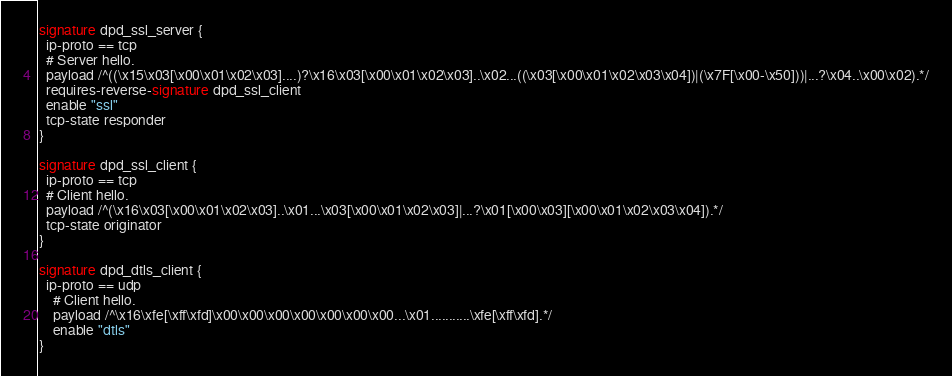Convert code to text. <code><loc_0><loc_0><loc_500><loc_500><_SML_>signature dpd_ssl_server {
  ip-proto == tcp
  # Server hello.
  payload /^((\x15\x03[\x00\x01\x02\x03]....)?\x16\x03[\x00\x01\x02\x03]..\x02...((\x03[\x00\x01\x02\x03\x04])|(\x7F[\x00-\x50]))|...?\x04..\x00\x02).*/
  requires-reverse-signature dpd_ssl_client
  enable "ssl"
  tcp-state responder
}

signature dpd_ssl_client {
  ip-proto == tcp
  # Client hello.
  payload /^(\x16\x03[\x00\x01\x02\x03]..\x01...\x03[\x00\x01\x02\x03]|...?\x01[\x00\x03][\x00\x01\x02\x03\x04]).*/
  tcp-state originator
}

signature dpd_dtls_client {
  ip-proto == udp
	# Client hello.
	payload /^\x16\xfe[\xff\xfd]\x00\x00\x00\x00\x00\x00\x00...\x01...........\xfe[\xff\xfd].*/
	enable "dtls"
}
</code> 